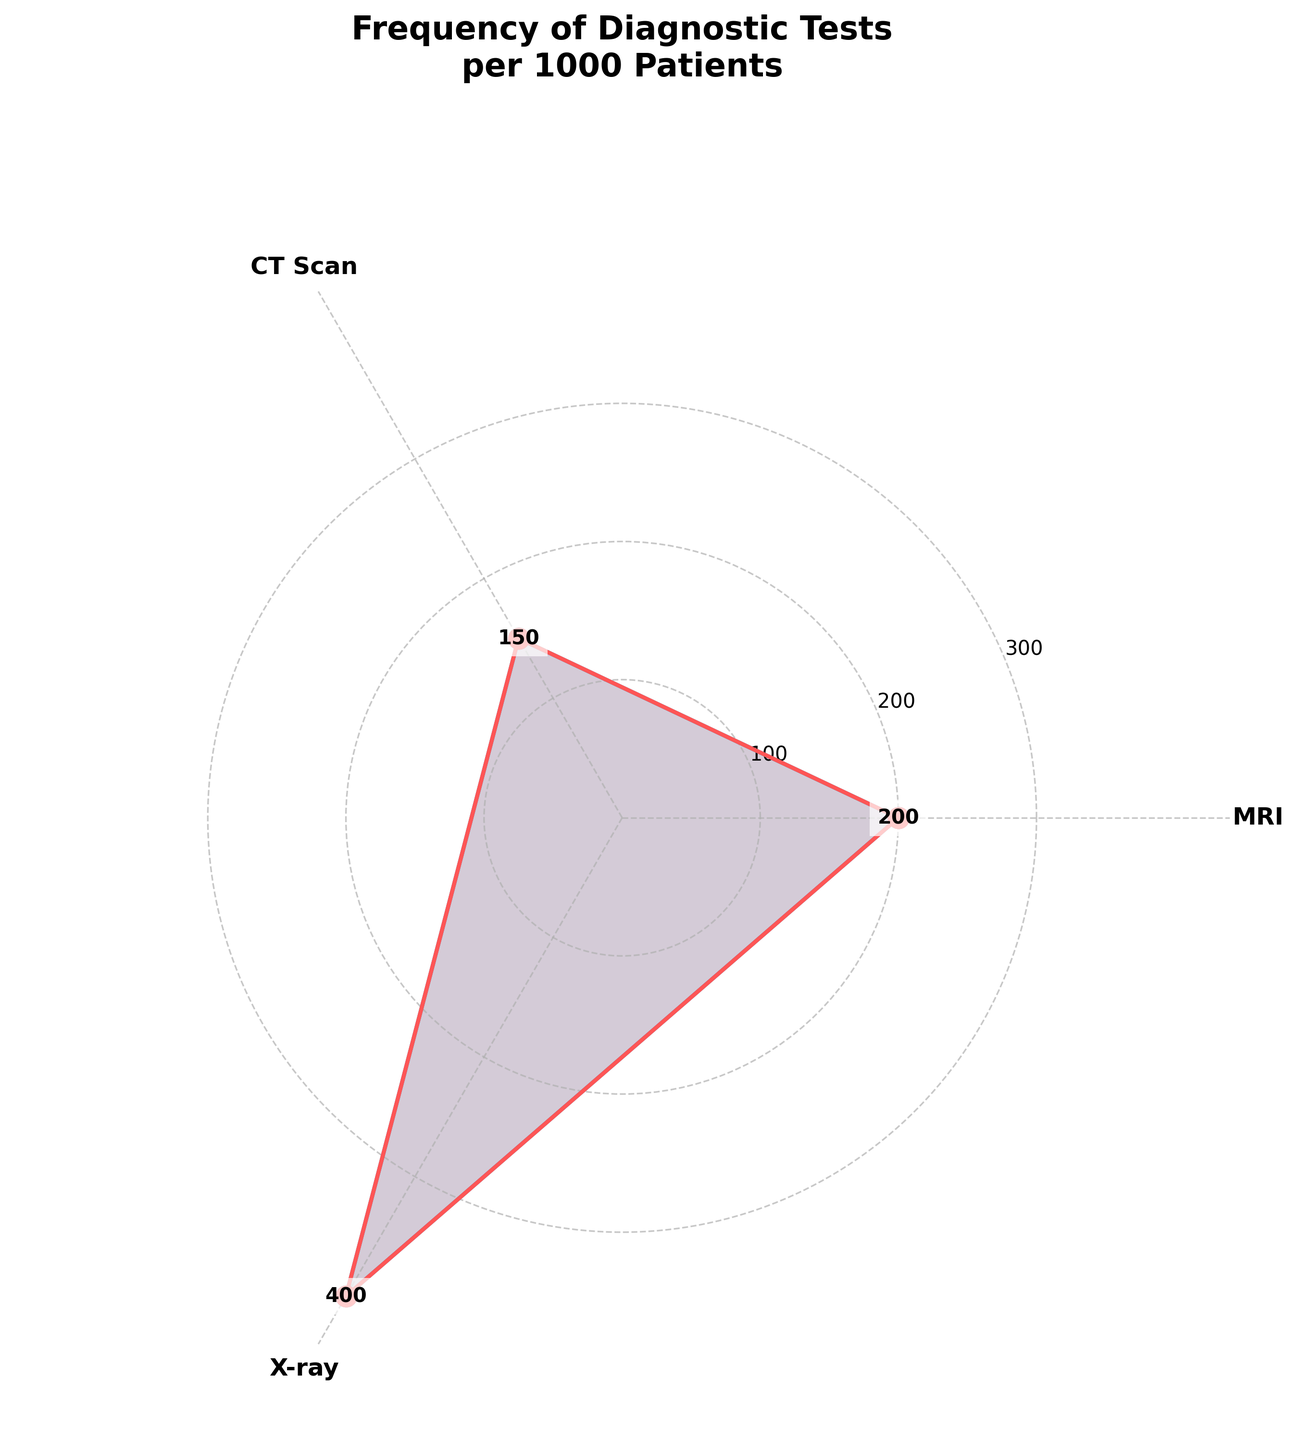What is the title of the chart? The chart title is usually displayed at the top of the figure. By looking at the figure, you can see that the title specifies the context of the data being presented.
Answer: Frequency of Diagnostic Tests per 1000 Patients How many different diagnostic tests are represented in the chart? By counting the number of segments or categories within the chart, you can determine the number of diagnostic tests included. Each segment is also labeled with the name of the test.
Answer: 3 Which diagnostic test is performed most frequently? To find the most frequent test, compare the values associated with each test. The segment representing the highest value indicates the most frequently performed test.
Answer: X-ray What is the frequency of the least performed diagnostic test? Identify the segment or category with the smallest value. This value represents the frequency of the least performed diagnostic test.
Answer: 150 Calculate the total frequency of all diagnostic tests combined. Sum the values of each category: MRI (200), CT Scan (150), and X-ray (400). The total frequency is the sum of these values.
Answer: 750 Which diagnostic test has a frequency exactly in between the most and least performed tests? First, identify the most and least performed tests (X-ray and CT Scan respectively). The remaining test (MRI) will have a value between these two.
Answer: MRI By how much does the frequency of the most performed test exceed the least performed test? Subtract the value of the least performed test (CT Scan) from the value of the most performed test (X-ray).
Answer: 250 What is the average frequency of the diagnostic tests? Sum the frequencies of all tests (MRI: 200, CT Scan: 150, X-ray: 400) which equals 750. Divide this total by the number of tests (3).
Answer: 250 Compare the frequency of MRI to X-ray. How many times higher is the X-ray frequency than the MRI frequency? Divide the X-ray frequency (400) by the MRI frequency (200). The result shows how many times higher the X-ray frequency is.
Answer: 2 times In which sector is the value label closest to the center of the chart? Look for the value label positioned nearest to the center of the chart. This label represents the smallest frequency value.
Answer: CT Scan 